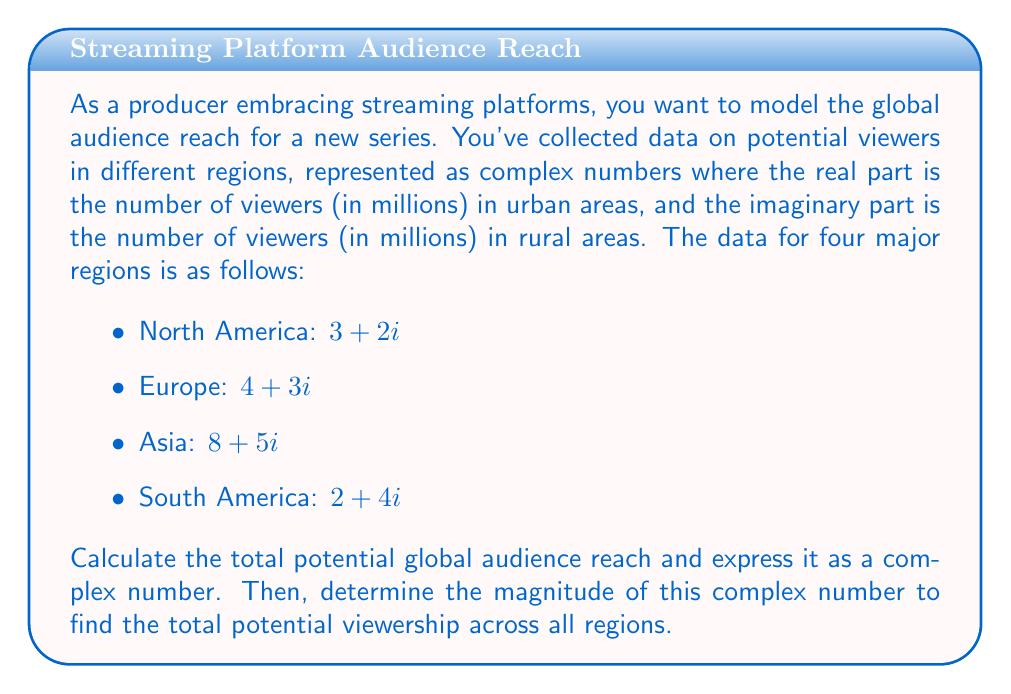Provide a solution to this math problem. To solve this problem, we'll follow these steps:

1) Add the complex numbers representing each region to get the total global audience reach.
2) Calculate the magnitude of the resulting complex number.

Step 1: Adding the complex numbers

Let's add the complex numbers for each region:

$$(3 + 2i) + (4 + 3i) + (8 + 5i) + (2 + 4i)$$

We can add the real and imaginary parts separately:

Real part: $3 + 4 + 8 + 2 = 17$
Imaginary part: $2 + 3 + 5 + 4 = 14$

So, the total global audience reach is represented by the complex number:

$$17 + 14i$$

Step 2: Calculating the magnitude

The magnitude of a complex number $a + bi$ is given by the formula:

$$|a + bi| = \sqrt{a^2 + b^2}$$

In this case, $a = 17$ and $b = 14$. Let's substitute these values:

$$|17 + 14i| = \sqrt{17^2 + 14^2}$$

$$= \sqrt{289 + 196}$$

$$= \sqrt{485}$$

$$\approx 22.02$$

This means the total potential viewership across all regions is approximately 22.02 million viewers.
Answer: The total potential global audience reach is represented by the complex number $17 + 14i$, with a magnitude of approximately 22.02 million viewers. 